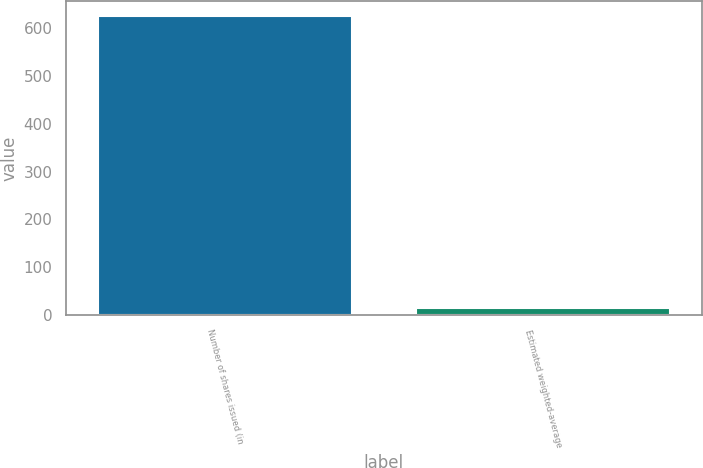Convert chart. <chart><loc_0><loc_0><loc_500><loc_500><bar_chart><fcel>Number of shares issued (in<fcel>Estimated weighted-average<nl><fcel>625<fcel>15.42<nl></chart> 